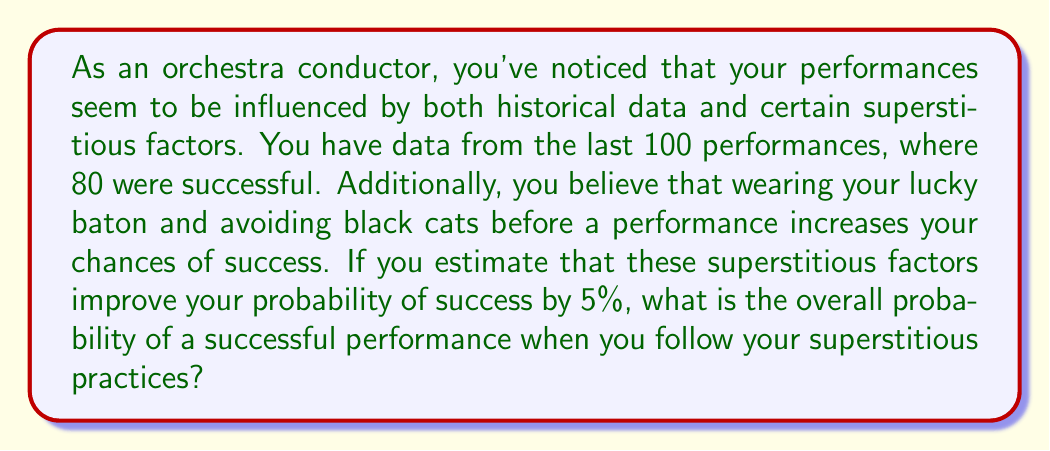Can you solve this math problem? Let's approach this step-by-step:

1. Calculate the base probability of success from historical data:
   $$P(\text{success}) = \frac{\text{number of successful performances}}{\text{total number of performances}} = \frac{80}{100} = 0.8$$

2. Convert the superstitious factor improvement to a decimal:
   $$\text{Superstitious improvement} = 5\% = 0.05$$

3. To incorporate the superstitious factor, we need to add this improvement to the base probability. However, we can't simply add 0.05 to 0.8, as this could result in a probability greater than 1, which is impossible.

4. Instead, we should consider the superstitious factor as reducing the probability of failure. The probability of failure is:
   $$P(\text{failure}) = 1 - P(\text{success}) = 1 - 0.8 = 0.2$$

5. Reduce the failure probability by 5%:
   $$P(\text{failure with superstition}) = 0.2 \times (1 - 0.05) = 0.2 \times 0.95 = 0.19$$

6. Calculate the new success probability:
   $$P(\text{success with superstition}) = 1 - P(\text{failure with superstition}) = 1 - 0.19 = 0.81$$

Therefore, the overall probability of a successful performance when following superstitious practices is 0.81 or 81%.
Answer: 0.81 